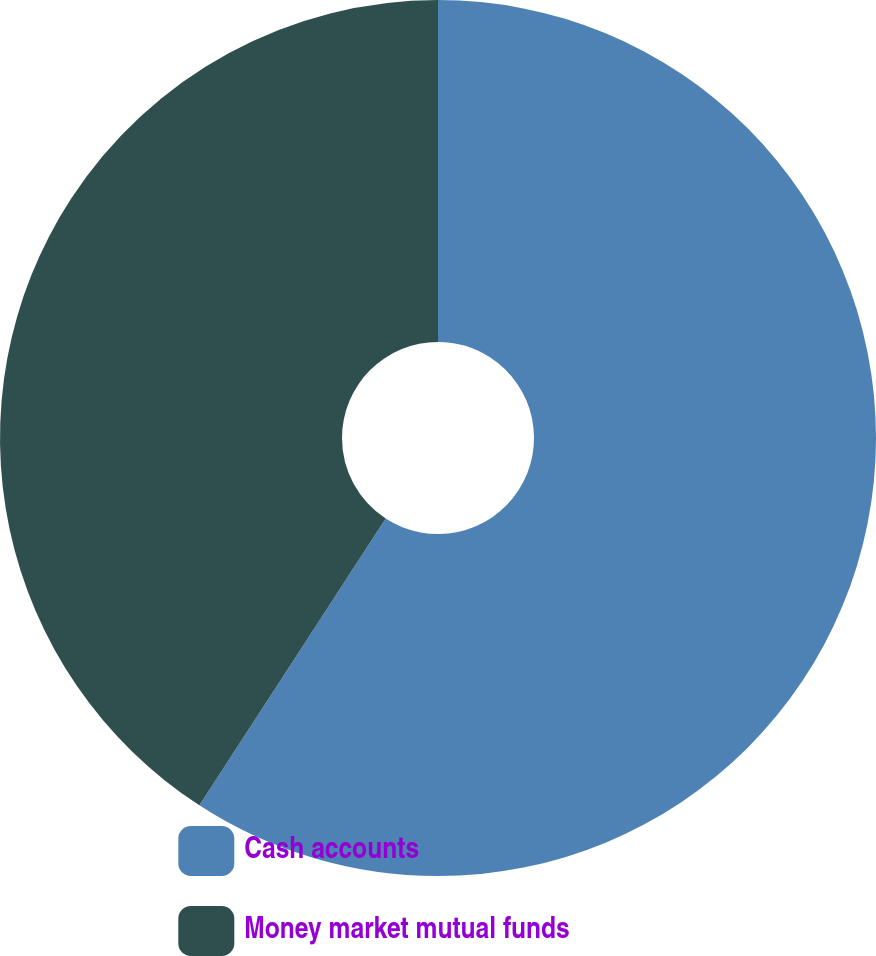Convert chart. <chart><loc_0><loc_0><loc_500><loc_500><pie_chart><fcel>Cash accounts<fcel>Money market mutual funds<nl><fcel>59.17%<fcel>40.83%<nl></chart> 